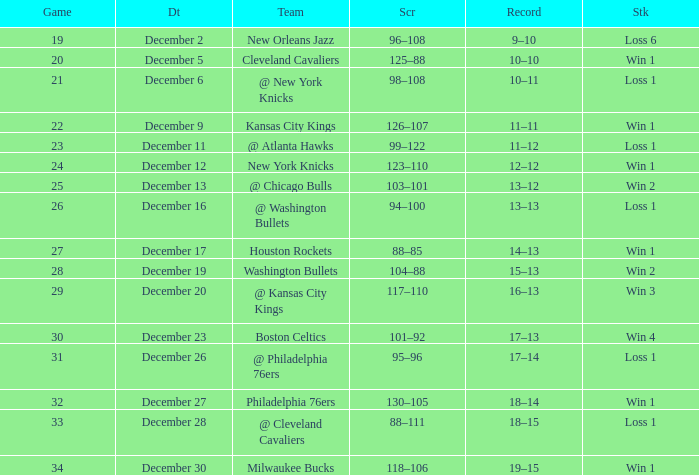What is the Score of the Game with a Record of 13–12? 103–101. 